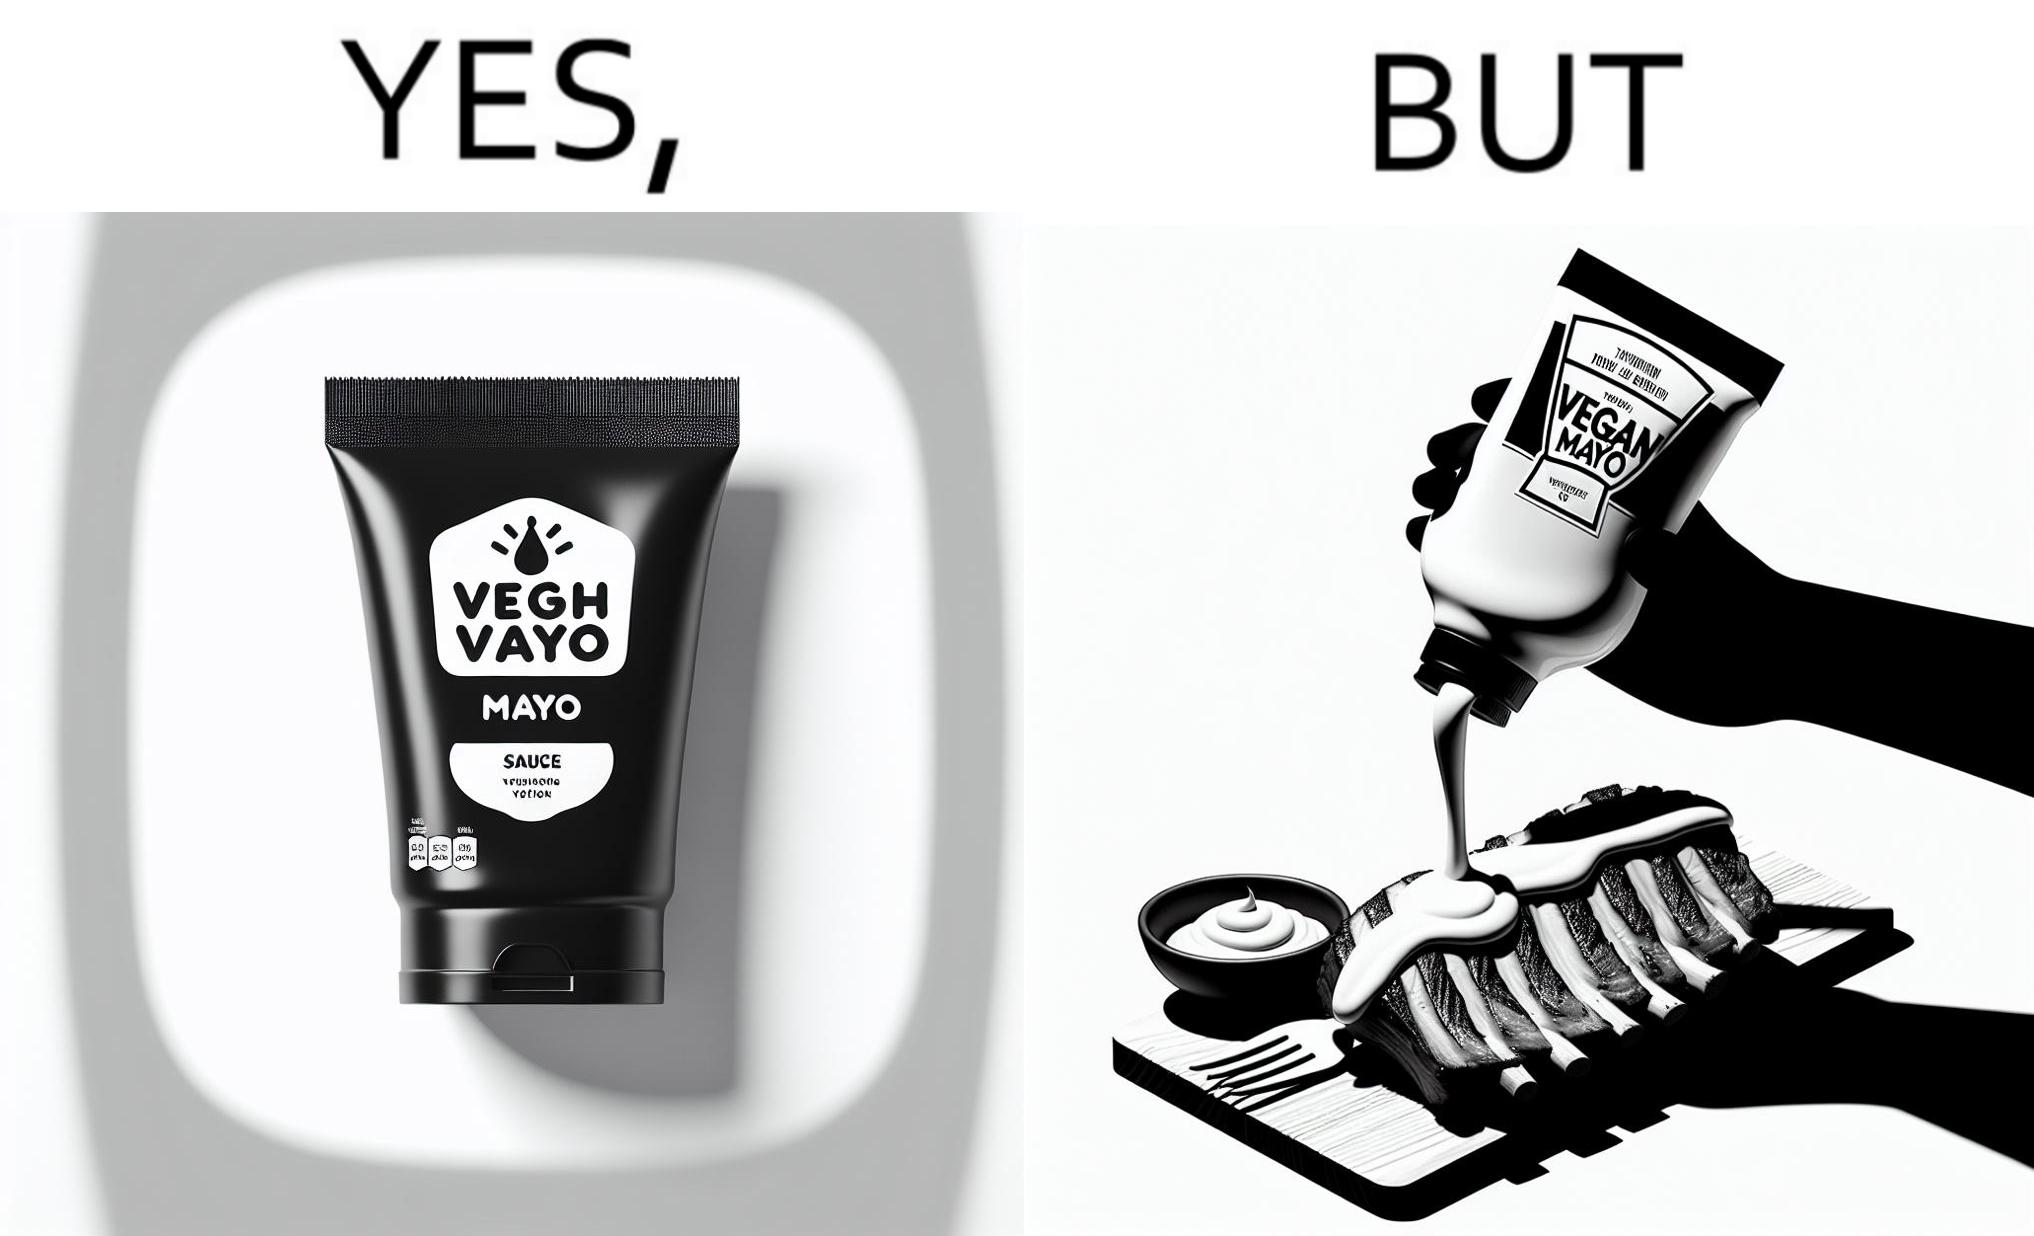Explain why this image is satirical. The image is ironical, as vegan mayo sauce is being poured on rib steak, which is non-vegetarian. The person might as well just use normal mayo sauce instead. 